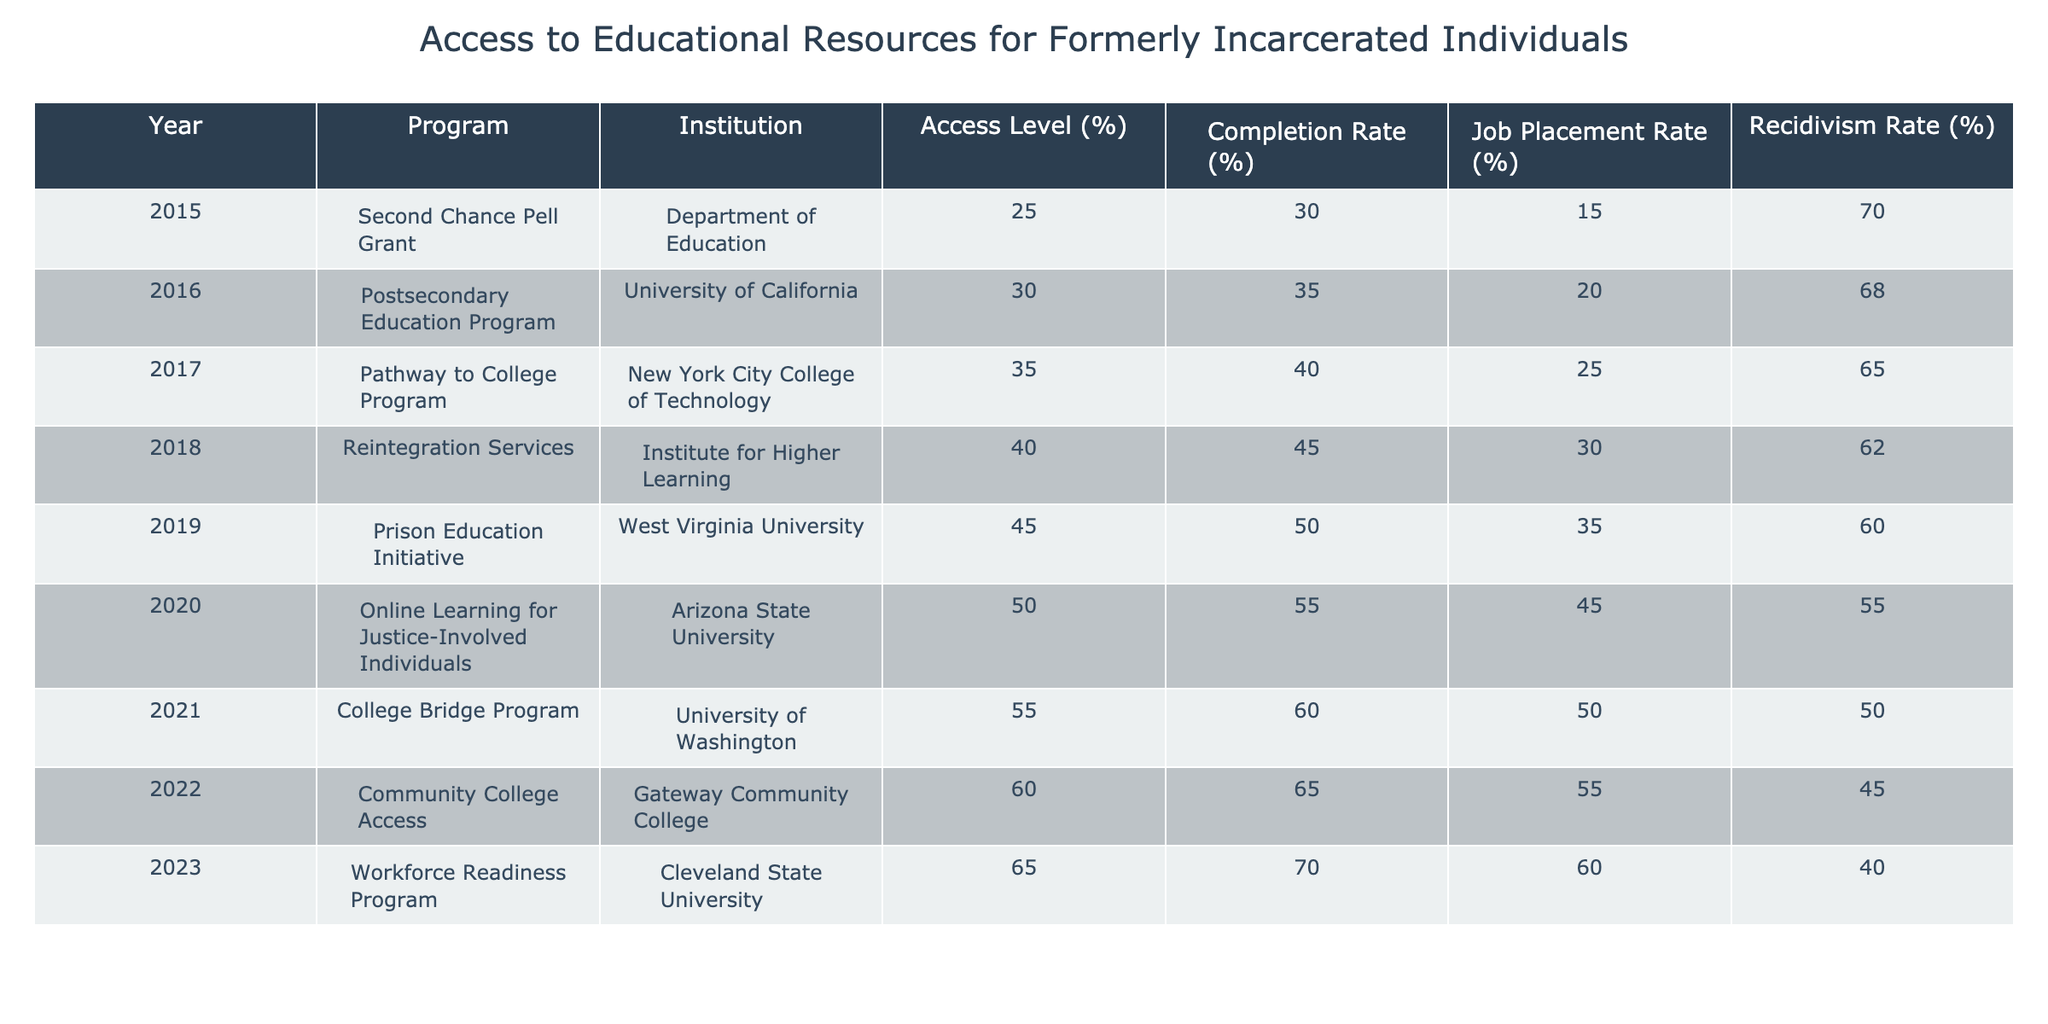What was the job placement rate for the Prison Education Initiative in 2019? From the table, I can refer to the row for the year 2019 and find that the job placement rate under the Prison Education Initiative was 35%.
Answer: 35% Which program in 2021 had the highest completion rate? By examining the 2021 row, the College Bridge Program shows a completion rate of 60%, which is the highest compared to the other programs in that year.
Answer: College Bridge Program What is the average access level for all programs from 2015 to 2023? To find the average access level, I will sum the access levels from all the years: 25 + 30 + 35 + 40 + 45 + 50 + 55 + 60 + 65 = 405. There are 9 programs, so the average is 405 / 9 = 45.
Answer: 45 Was the recidivism rate lower in 2023 than in 2015? In 2023, the recidivism rate is 40%, while in 2015 it was 70%. Since 40% is less than 70%, the statement is true.
Answer: Yes Which institution had the best job placement rate in 2020? In 2020, the Online Learning for Justice-Involved Individuals program had a job placement rate of 45%. Comparatively, looking at all institutions from 2015 to 2023, this is the highest for that year.
Answer: Arizona State University How much did the completion rate increase from 2015 to 2023? The completion rate in 2015 was 30%, and by 2023 it increased to 70%. The increase is calculated by subtracting the earlier rate from the later rate: 70 - 30 = 40.
Answer: 40% Which program had an access level of 55% and what was its recidivism rate? The program with an access level of 55% was the College Bridge Program in 2021, and the corresponding recidivism rate for that year was 50%.
Answer: College Bridge Program, 50% Was the access level for the Reintegration Services program greater than 35%? Looking at the row for the Reintegration Services in 2018, the access level was 40%. This is greater than 35%, so the answer is yes.
Answer: Yes What year saw the largest increase in access level from the previous year? Examining the access levels from 2015 to 2023, the largest increase occurred from 2022 to 2023, where it rose from 60% to 65%. This is an increase of 5%.
Answer: 2022 to 2023 